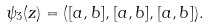Convert formula to latex. <formula><loc_0><loc_0><loc_500><loc_500>\psi _ { 3 } ( z ) = ( [ a , b ] , [ a , b ] , [ a , b ] ) .</formula> 